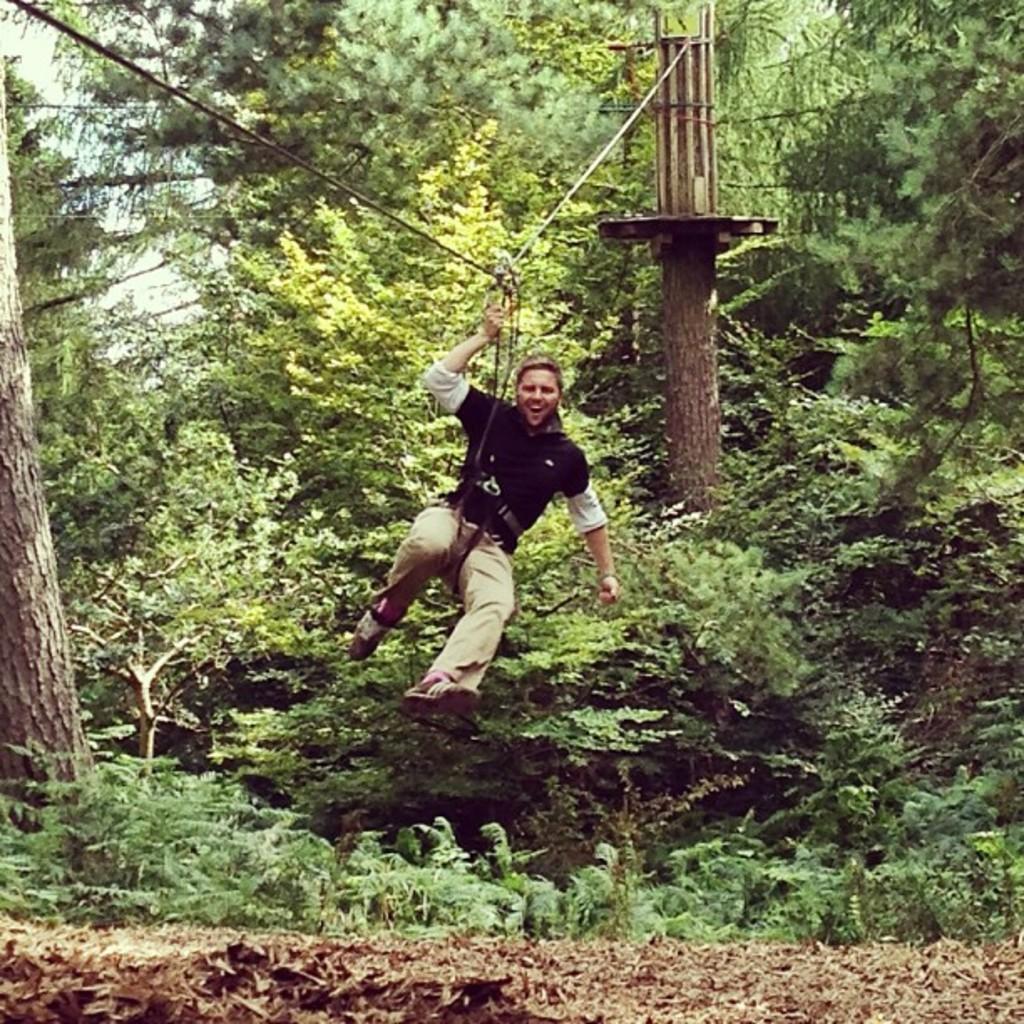In one or two sentences, can you explain what this image depicts? In the picture we can see a forest area with trees and plants and two pillars with a wire and a person tied to it. 